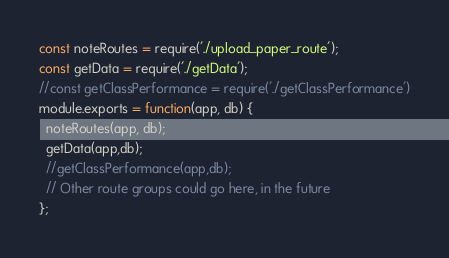Convert code to text. <code><loc_0><loc_0><loc_500><loc_500><_JavaScript_>const noteRoutes = require('./upload_paper_route');
const getData = require('./getData');
//const getClassPerformance = require('./getClassPerformance')
module.exports = function(app, db) {
  noteRoutes(app, db);
  getData(app,db);
  //getClassPerformance(app,db);
  // Other route groups could go here, in the future
};
</code> 